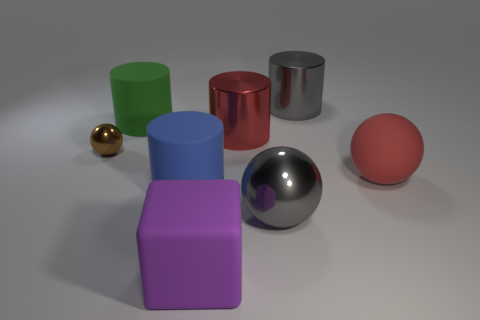There is a metal thing left of the rubber cylinder behind the tiny brown sphere; is there a purple object on the left side of it?
Your response must be concise. No. Is the small thing the same color as the big shiny ball?
Your response must be concise. No. Is the number of purple things less than the number of rubber cylinders?
Keep it short and to the point. Yes. Is the material of the big thing that is on the right side of the large gray metal cylinder the same as the big blue cylinder that is behind the large cube?
Your answer should be very brief. Yes. Are there fewer large blue rubber cylinders that are behind the tiny thing than blue cylinders?
Make the answer very short. Yes. How many large blue matte cylinders are behind the big metal cylinder that is to the left of the large gray cylinder?
Offer a terse response. 0. There is a ball that is behind the big gray shiny sphere and in front of the tiny sphere; how big is it?
Keep it short and to the point. Large. Is there any other thing that has the same material as the large purple cube?
Offer a terse response. Yes. Is the big red sphere made of the same material as the big red thing on the left side of the large gray metal sphere?
Make the answer very short. No. Are there fewer big blocks behind the big gray metal cylinder than purple rubber objects that are behind the large green thing?
Your answer should be very brief. No. 